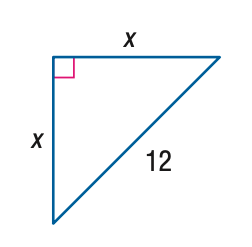Question: Find x.
Choices:
A. 6 \sqrt { 2 }
B. 6 \sqrt { 3 }
C. 12 \sqrt { 2 }
D. 12 \sqrt { 3 }
Answer with the letter. Answer: A 